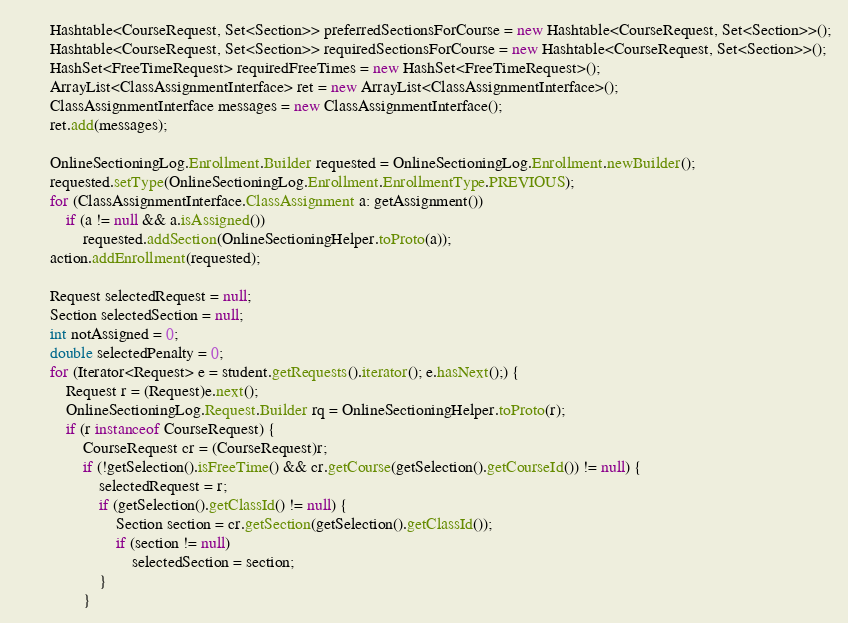<code> <loc_0><loc_0><loc_500><loc_500><_Java_>		Hashtable<CourseRequest, Set<Section>> preferredSectionsForCourse = new Hashtable<CourseRequest, Set<Section>>();
		Hashtable<CourseRequest, Set<Section>> requiredSectionsForCourse = new Hashtable<CourseRequest, Set<Section>>();
		HashSet<FreeTimeRequest> requiredFreeTimes = new HashSet<FreeTimeRequest>();
        ArrayList<ClassAssignmentInterface> ret = new ArrayList<ClassAssignmentInterface>();
        ClassAssignmentInterface messages = new ClassAssignmentInterface();
        ret.add(messages);
        
		OnlineSectioningLog.Enrollment.Builder requested = OnlineSectioningLog.Enrollment.newBuilder();
		requested.setType(OnlineSectioningLog.Enrollment.EnrollmentType.PREVIOUS);
		for (ClassAssignmentInterface.ClassAssignment a: getAssignment())
			if (a != null && a.isAssigned())
				requested.addSection(OnlineSectioningHelper.toProto(a));
		action.addEnrollment(requested);

		Request selectedRequest = null;
		Section selectedSection = null;
		int notAssigned = 0;
		double selectedPenalty = 0;
		for (Iterator<Request> e = student.getRequests().iterator(); e.hasNext();) {
			Request r = (Request)e.next();
			OnlineSectioningLog.Request.Builder rq = OnlineSectioningHelper.toProto(r); 
			if (r instanceof CourseRequest) {
				CourseRequest cr = (CourseRequest)r;
				if (!getSelection().isFreeTime() && cr.getCourse(getSelection().getCourseId()) != null) {
					selectedRequest = r;
					if (getSelection().getClassId() != null) {
						Section section = cr.getSection(getSelection().getClassId());
						if (section != null)
							selectedSection = section;
					}
				}</code> 